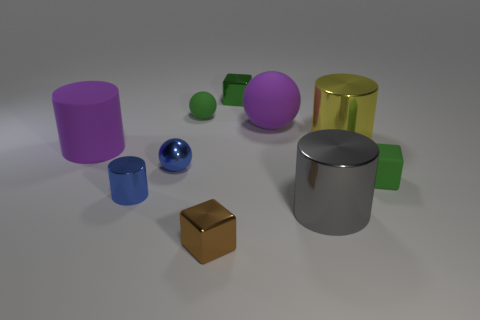There is a green metal object that is the same shape as the brown thing; what is its size? The green metal object appears to be a scaled-down version of the brown cube. While exact dimensions cannot be determined from the image alone, it is visually smaller in comparison to the brown cube and other objects in the image. 